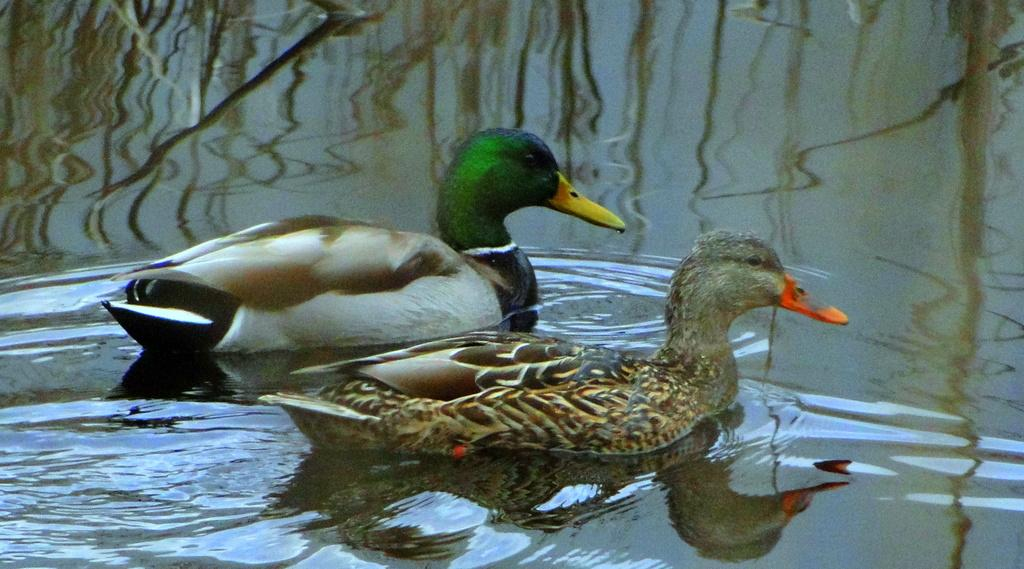What animals are present in the image? There are two ducks in the image. Where are the ducks located? The ducks are in the water. How many hooks can be seen in the image? There are no hooks present in the image; it features two ducks in the water. 